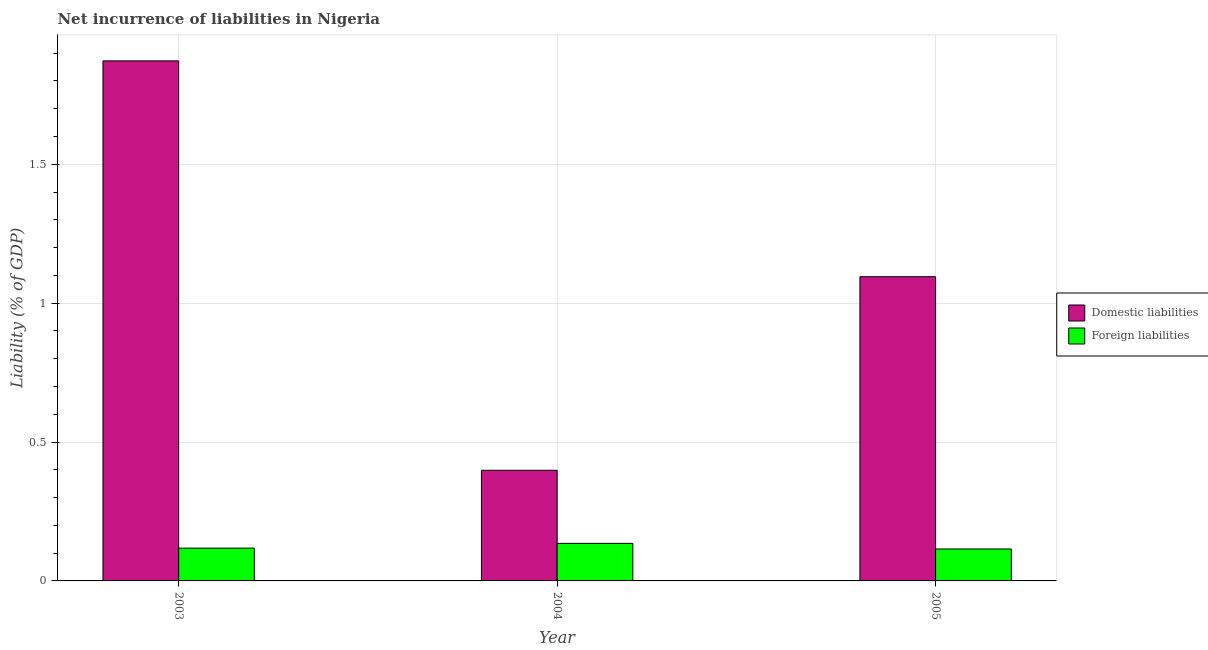Are the number of bars on each tick of the X-axis equal?
Your response must be concise. Yes. How many bars are there on the 1st tick from the left?
Offer a terse response. 2. How many bars are there on the 2nd tick from the right?
Ensure brevity in your answer.  2. What is the label of the 3rd group of bars from the left?
Ensure brevity in your answer.  2005. In how many cases, is the number of bars for a given year not equal to the number of legend labels?
Your answer should be compact. 0. What is the incurrence of foreign liabilities in 2005?
Provide a short and direct response. 0.12. Across all years, what is the maximum incurrence of domestic liabilities?
Give a very brief answer. 1.87. Across all years, what is the minimum incurrence of domestic liabilities?
Offer a very short reply. 0.4. In which year was the incurrence of domestic liabilities maximum?
Provide a short and direct response. 2003. What is the total incurrence of foreign liabilities in the graph?
Keep it short and to the point. 0.37. What is the difference between the incurrence of domestic liabilities in 2004 and that in 2005?
Provide a succinct answer. -0.7. What is the difference between the incurrence of domestic liabilities in 2005 and the incurrence of foreign liabilities in 2003?
Provide a short and direct response. -0.78. What is the average incurrence of foreign liabilities per year?
Offer a terse response. 0.12. What is the ratio of the incurrence of domestic liabilities in 2003 to that in 2005?
Your response must be concise. 1.71. Is the incurrence of foreign liabilities in 2003 less than that in 2005?
Your answer should be compact. No. Is the difference between the incurrence of foreign liabilities in 2003 and 2004 greater than the difference between the incurrence of domestic liabilities in 2003 and 2004?
Provide a succinct answer. No. What is the difference between the highest and the second highest incurrence of foreign liabilities?
Your answer should be very brief. 0.02. What is the difference between the highest and the lowest incurrence of foreign liabilities?
Offer a very short reply. 0.02. In how many years, is the incurrence of domestic liabilities greater than the average incurrence of domestic liabilities taken over all years?
Provide a short and direct response. 1. Is the sum of the incurrence of foreign liabilities in 2003 and 2005 greater than the maximum incurrence of domestic liabilities across all years?
Make the answer very short. Yes. What does the 2nd bar from the left in 2004 represents?
Provide a short and direct response. Foreign liabilities. What does the 2nd bar from the right in 2003 represents?
Make the answer very short. Domestic liabilities. How many bars are there?
Your answer should be compact. 6. Are all the bars in the graph horizontal?
Offer a very short reply. No. How many years are there in the graph?
Your response must be concise. 3. What is the difference between two consecutive major ticks on the Y-axis?
Offer a terse response. 0.5. Are the values on the major ticks of Y-axis written in scientific E-notation?
Offer a terse response. No. Does the graph contain any zero values?
Ensure brevity in your answer.  No. Where does the legend appear in the graph?
Your answer should be compact. Center right. How many legend labels are there?
Provide a succinct answer. 2. How are the legend labels stacked?
Your answer should be compact. Vertical. What is the title of the graph?
Your answer should be very brief. Net incurrence of liabilities in Nigeria. Does "Females" appear as one of the legend labels in the graph?
Provide a short and direct response. No. What is the label or title of the X-axis?
Your answer should be compact. Year. What is the label or title of the Y-axis?
Ensure brevity in your answer.  Liability (% of GDP). What is the Liability (% of GDP) in Domestic liabilities in 2003?
Offer a terse response. 1.87. What is the Liability (% of GDP) in Foreign liabilities in 2003?
Keep it short and to the point. 0.12. What is the Liability (% of GDP) in Domestic liabilities in 2004?
Your answer should be very brief. 0.4. What is the Liability (% of GDP) of Foreign liabilities in 2004?
Provide a succinct answer. 0.14. What is the Liability (% of GDP) in Domestic liabilities in 2005?
Give a very brief answer. 1.1. What is the Liability (% of GDP) in Foreign liabilities in 2005?
Your answer should be very brief. 0.12. Across all years, what is the maximum Liability (% of GDP) in Domestic liabilities?
Offer a terse response. 1.87. Across all years, what is the maximum Liability (% of GDP) in Foreign liabilities?
Your response must be concise. 0.14. Across all years, what is the minimum Liability (% of GDP) of Domestic liabilities?
Offer a very short reply. 0.4. Across all years, what is the minimum Liability (% of GDP) in Foreign liabilities?
Your answer should be very brief. 0.12. What is the total Liability (% of GDP) of Domestic liabilities in the graph?
Your answer should be compact. 3.37. What is the total Liability (% of GDP) of Foreign liabilities in the graph?
Offer a very short reply. 0.37. What is the difference between the Liability (% of GDP) of Domestic liabilities in 2003 and that in 2004?
Your answer should be very brief. 1.47. What is the difference between the Liability (% of GDP) of Foreign liabilities in 2003 and that in 2004?
Your answer should be compact. -0.02. What is the difference between the Liability (% of GDP) in Domestic liabilities in 2003 and that in 2005?
Your answer should be very brief. 0.78. What is the difference between the Liability (% of GDP) of Foreign liabilities in 2003 and that in 2005?
Offer a terse response. 0. What is the difference between the Liability (% of GDP) in Domestic liabilities in 2004 and that in 2005?
Provide a short and direct response. -0.7. What is the difference between the Liability (% of GDP) of Foreign liabilities in 2004 and that in 2005?
Your answer should be compact. 0.02. What is the difference between the Liability (% of GDP) in Domestic liabilities in 2003 and the Liability (% of GDP) in Foreign liabilities in 2004?
Provide a succinct answer. 1.74. What is the difference between the Liability (% of GDP) of Domestic liabilities in 2003 and the Liability (% of GDP) of Foreign liabilities in 2005?
Your answer should be compact. 1.76. What is the difference between the Liability (% of GDP) in Domestic liabilities in 2004 and the Liability (% of GDP) in Foreign liabilities in 2005?
Offer a very short reply. 0.28. What is the average Liability (% of GDP) of Domestic liabilities per year?
Provide a succinct answer. 1.12. What is the average Liability (% of GDP) of Foreign liabilities per year?
Make the answer very short. 0.12. In the year 2003, what is the difference between the Liability (% of GDP) of Domestic liabilities and Liability (% of GDP) of Foreign liabilities?
Ensure brevity in your answer.  1.75. In the year 2004, what is the difference between the Liability (% of GDP) of Domestic liabilities and Liability (% of GDP) of Foreign liabilities?
Your answer should be compact. 0.26. In the year 2005, what is the difference between the Liability (% of GDP) in Domestic liabilities and Liability (% of GDP) in Foreign liabilities?
Give a very brief answer. 0.98. What is the ratio of the Liability (% of GDP) of Domestic liabilities in 2003 to that in 2004?
Make the answer very short. 4.7. What is the ratio of the Liability (% of GDP) in Foreign liabilities in 2003 to that in 2004?
Offer a very short reply. 0.87. What is the ratio of the Liability (% of GDP) of Domestic liabilities in 2003 to that in 2005?
Your answer should be compact. 1.71. What is the ratio of the Liability (% of GDP) in Foreign liabilities in 2003 to that in 2005?
Your answer should be very brief. 1.03. What is the ratio of the Liability (% of GDP) in Domestic liabilities in 2004 to that in 2005?
Give a very brief answer. 0.36. What is the ratio of the Liability (% of GDP) of Foreign liabilities in 2004 to that in 2005?
Provide a short and direct response. 1.18. What is the difference between the highest and the second highest Liability (% of GDP) of Domestic liabilities?
Provide a short and direct response. 0.78. What is the difference between the highest and the second highest Liability (% of GDP) of Foreign liabilities?
Offer a very short reply. 0.02. What is the difference between the highest and the lowest Liability (% of GDP) of Domestic liabilities?
Give a very brief answer. 1.47. What is the difference between the highest and the lowest Liability (% of GDP) of Foreign liabilities?
Provide a short and direct response. 0.02. 